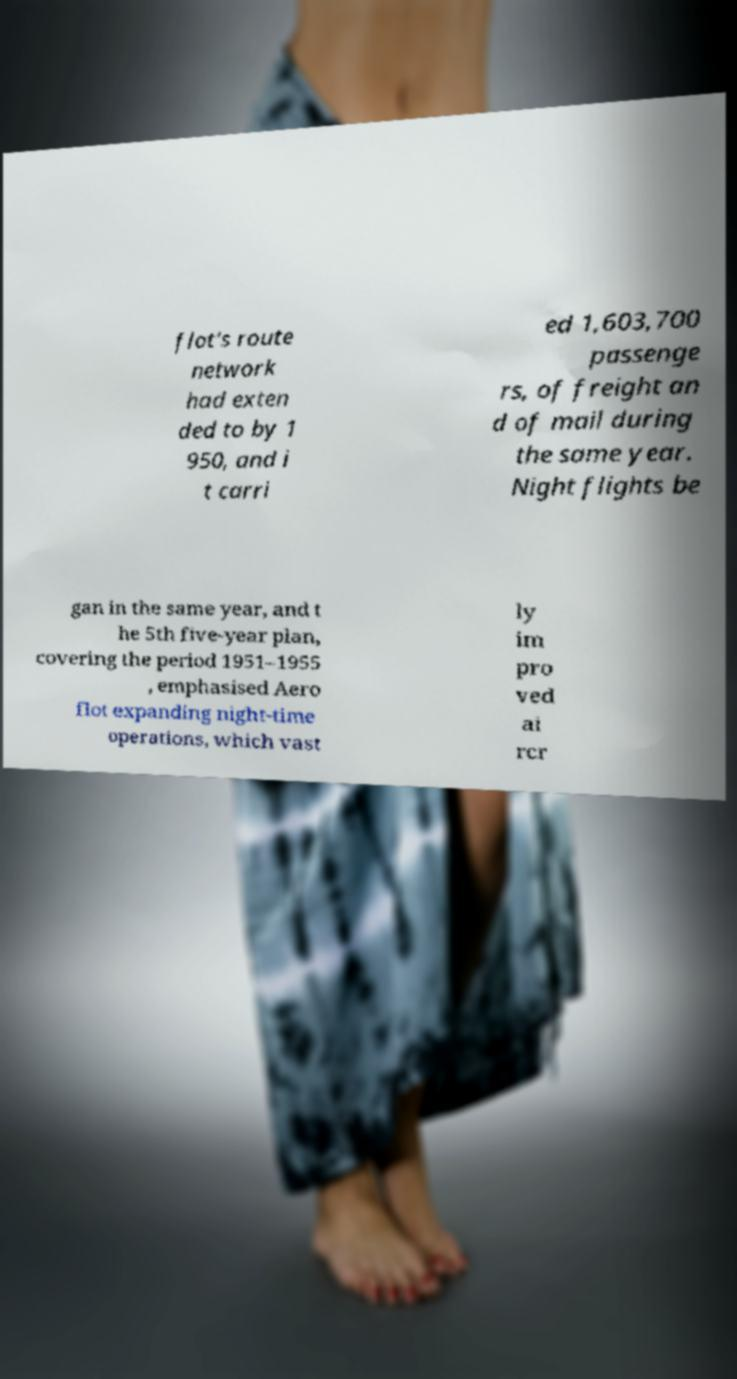Can you accurately transcribe the text from the provided image for me? flot's route network had exten ded to by 1 950, and i t carri ed 1,603,700 passenge rs, of freight an d of mail during the same year. Night flights be gan in the same year, and t he 5th five-year plan, covering the period 1951–1955 , emphasised Aero flot expanding night-time operations, which vast ly im pro ved ai rcr 